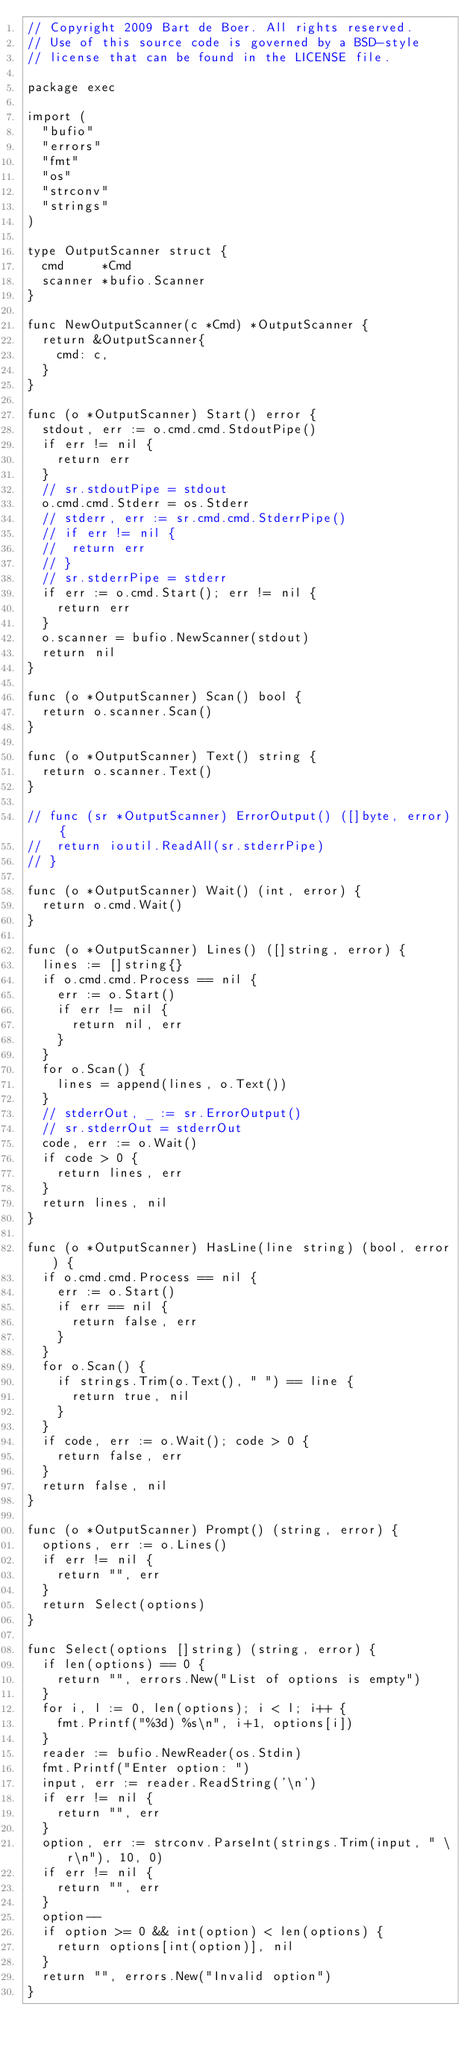<code> <loc_0><loc_0><loc_500><loc_500><_Go_>// Copyright 2009 Bart de Boer. All rights reserved.
// Use of this source code is governed by a BSD-style
// license that can be found in the LICENSE file.

package exec

import (
	"bufio"
	"errors"
	"fmt"
	"os"
	"strconv"
	"strings"
)

type OutputScanner struct {
	cmd     *Cmd
	scanner *bufio.Scanner
}

func NewOutputScanner(c *Cmd) *OutputScanner {
	return &OutputScanner{
		cmd: c,
	}
}

func (o *OutputScanner) Start() error {
	stdout, err := o.cmd.cmd.StdoutPipe()
	if err != nil {
		return err
	}
	// sr.stdoutPipe = stdout
	o.cmd.cmd.Stderr = os.Stderr
	// stderr, err := sr.cmd.cmd.StderrPipe()
	// if err != nil {
	// 	return err
	// }
	// sr.stderrPipe = stderr
	if err := o.cmd.Start(); err != nil {
		return err
	}
	o.scanner = bufio.NewScanner(stdout)
	return nil
}

func (o *OutputScanner) Scan() bool {
	return o.scanner.Scan()
}

func (o *OutputScanner) Text() string {
	return o.scanner.Text()
}

// func (sr *OutputScanner) ErrorOutput() ([]byte, error) {
// 	return ioutil.ReadAll(sr.stderrPipe)
// }

func (o *OutputScanner) Wait() (int, error) {
	return o.cmd.Wait()
}

func (o *OutputScanner) Lines() ([]string, error) {
	lines := []string{}
	if o.cmd.cmd.Process == nil {
		err := o.Start()
		if err != nil {
			return nil, err
		}
	}
	for o.Scan() {
		lines = append(lines, o.Text())
	}
	// stderrOut, _ := sr.ErrorOutput()
	// sr.stderrOut = stderrOut
	code, err := o.Wait()
	if code > 0 {
		return lines, err
	}
	return lines, nil
}

func (o *OutputScanner) HasLine(line string) (bool, error) {
	if o.cmd.cmd.Process == nil {
		err := o.Start()
		if err == nil {
			return false, err
		}
	}
	for o.Scan() {
		if strings.Trim(o.Text(), " ") == line {
			return true, nil
		}
	}
	if code, err := o.Wait(); code > 0 {
		return false, err
	}
	return false, nil
}

func (o *OutputScanner) Prompt() (string, error) {
	options, err := o.Lines()
	if err != nil {
		return "", err
	}
	return Select(options)
}

func Select(options []string) (string, error) {
	if len(options) == 0 {
		return "", errors.New("List of options is empty")
	}
	for i, l := 0, len(options); i < l; i++ {
		fmt.Printf("%3d) %s\n", i+1, options[i])
	}
	reader := bufio.NewReader(os.Stdin)
	fmt.Printf("Enter option: ")
	input, err := reader.ReadString('\n')
	if err != nil {
		return "", err
	}
	option, err := strconv.ParseInt(strings.Trim(input, " \r\n"), 10, 0)
	if err != nil {
		return "", err
	}
	option--
	if option >= 0 && int(option) < len(options) {
		return options[int(option)], nil
	}
	return "", errors.New("Invalid option")
}
</code> 